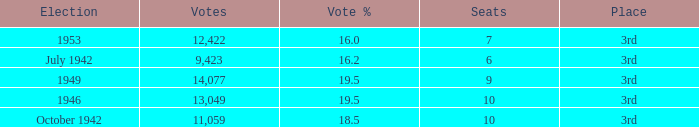Name the vote % for seats of 9 19.5. 